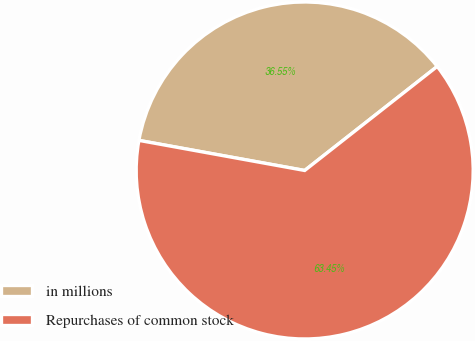Convert chart. <chart><loc_0><loc_0><loc_500><loc_500><pie_chart><fcel>in millions<fcel>Repurchases of common stock<nl><fcel>36.55%<fcel>63.45%<nl></chart> 